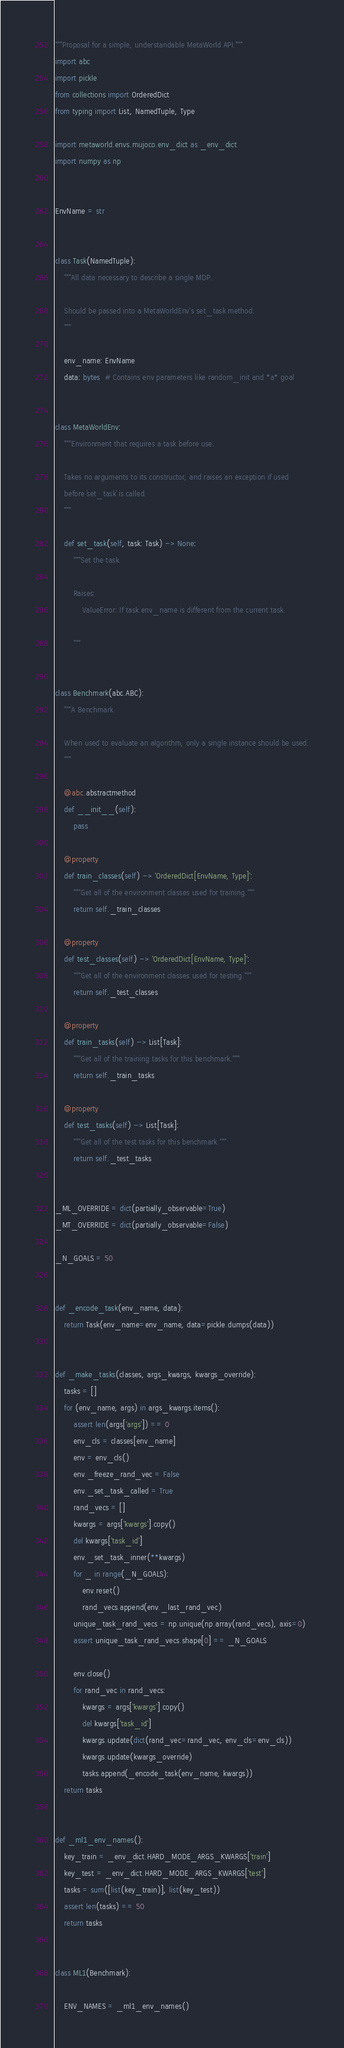<code> <loc_0><loc_0><loc_500><loc_500><_Python_>"""Proposal for a simple, understandable MetaWorld API."""
import abc
import pickle
from collections import OrderedDict
from typing import List, NamedTuple, Type

import metaworld.envs.mujoco.env_dict as _env_dict
import numpy as np


EnvName = str


class Task(NamedTuple):
    """All data necessary to describe a single MDP.

    Should be passed into a MetaWorldEnv's set_task method.
    """

    env_name: EnvName
    data: bytes  # Contains env parameters like random_init and *a* goal


class MetaWorldEnv:
    """Environment that requires a task before use.

    Takes no arguments to its constructor, and raises an exception if used
    before `set_task` is called.
    """

    def set_task(self, task: Task) -> None:
        """Set the task.

        Raises:
            ValueError: If task.env_name is different from the current task.

        """


class Benchmark(abc.ABC):
    """A Benchmark.

    When used to evaluate an algorithm, only a single instance should be used.
    """

    @abc.abstractmethod
    def __init__(self):
        pass

    @property
    def train_classes(self) -> 'OrderedDict[EnvName, Type]':
        """Get all of the environment classes used for training."""
        return self._train_classes

    @property
    def test_classes(self) -> 'OrderedDict[EnvName, Type]':
        """Get all of the environment classes used for testing."""
        return self._test_classes

    @property
    def train_tasks(self) -> List[Task]:
        """Get all of the training tasks for this benchmark."""
        return self._train_tasks

    @property
    def test_tasks(self) -> List[Task]:
        """Get all of the test tasks for this benchmark."""
        return self._test_tasks


_ML_OVERRIDE = dict(partially_observable=True)
_MT_OVERRIDE = dict(partially_observable=False)

_N_GOALS = 50


def _encode_task(env_name, data):
    return Task(env_name=env_name, data=pickle.dumps(data))


def _make_tasks(classes, args_kwargs, kwargs_override):
    tasks = []
    for (env_name, args) in args_kwargs.items():
        assert len(args['args']) == 0
        env_cls = classes[env_name]
        env = env_cls()
        env._freeze_rand_vec = False
        env._set_task_called = True
        rand_vecs = []
        kwargs = args['kwargs'].copy()
        del kwargs['task_id']
        env._set_task_inner(**kwargs)
        for _ in range(_N_GOALS):
            env.reset()
            rand_vecs.append(env._last_rand_vec)
        unique_task_rand_vecs = np.unique(np.array(rand_vecs), axis=0)
        assert unique_task_rand_vecs.shape[0] == _N_GOALS

        env.close()
        for rand_vec in rand_vecs:
            kwargs = args['kwargs'].copy()
            del kwargs['task_id']
            kwargs.update(dict(rand_vec=rand_vec, env_cls=env_cls))
            kwargs.update(kwargs_override)
            tasks.append(_encode_task(env_name, kwargs))
    return tasks


def _ml1_env_names():
    key_train = _env_dict.HARD_MODE_ARGS_KWARGS['train']
    key_test = _env_dict.HARD_MODE_ARGS_KWARGS['test']
    tasks = sum([list(key_train)], list(key_test))
    assert len(tasks) == 50
    return tasks


class ML1(Benchmark):

    ENV_NAMES = _ml1_env_names()
</code> 